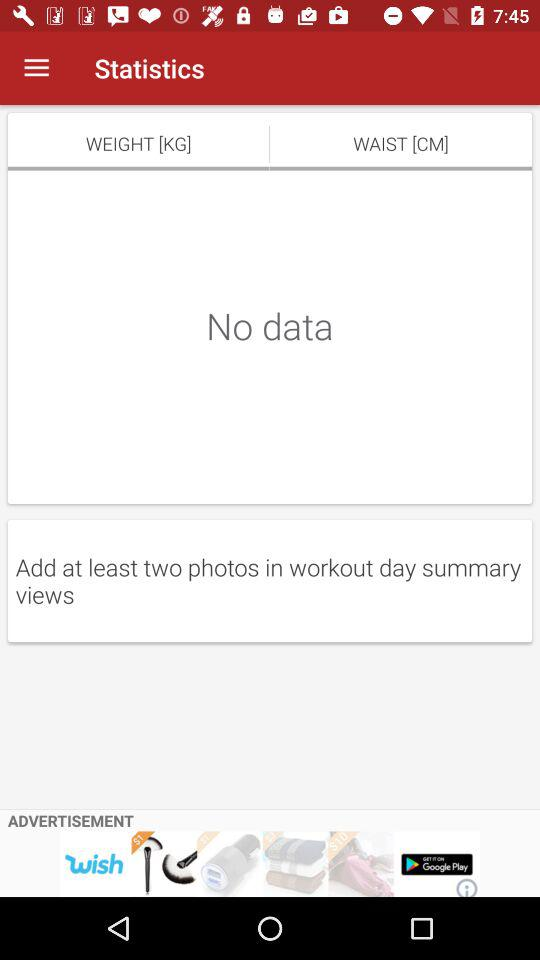What's the least number of photos that should be added to workout day summary views? The least number of photos that should be added to workout day summary views is two. 